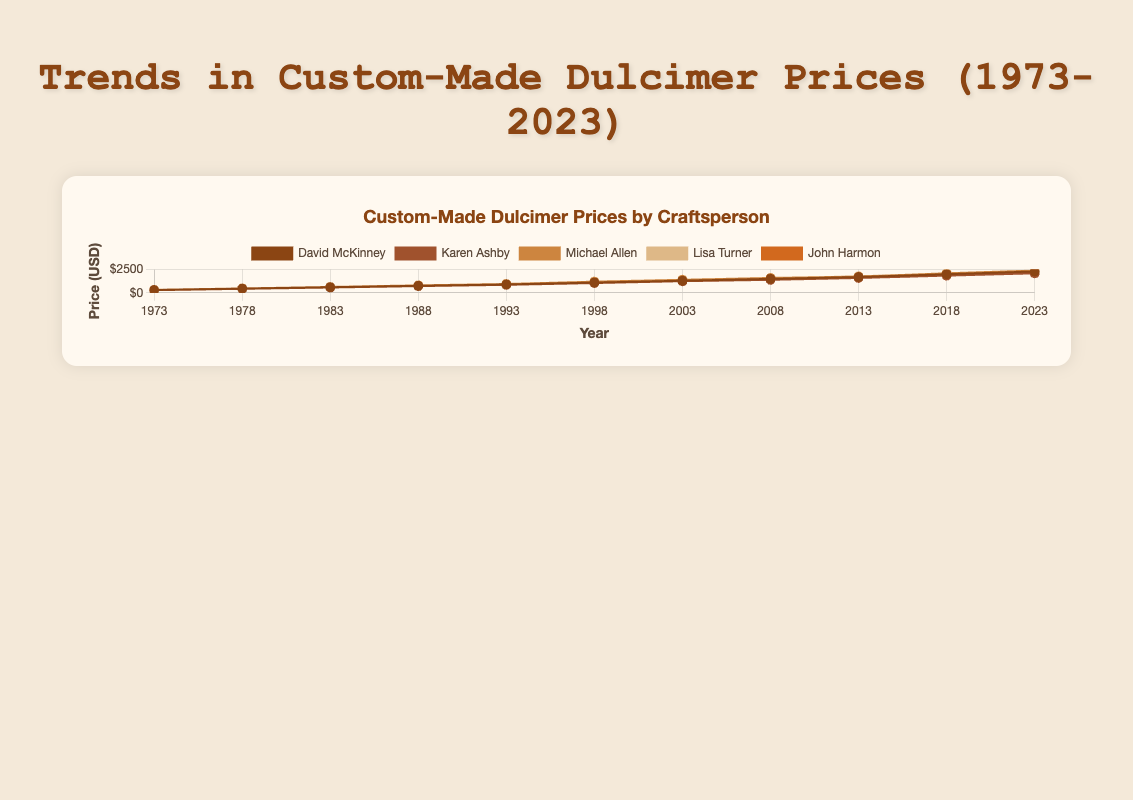Which craftsperson had the highest price for a dulcimer in 2023? To answer this, we look at the end of each line on the plot corresponding to 2023. The data points will show which craftsperson had the highest price. "Michael Allen" is the line that reaches $2400 in 2023.
Answer: Michael Allen Among all the crafters, who had the smallest price increment from 1973 to 2023? To find this, calculate the difference between the prices in 2023 and 1973 for each crafter. The differences are:
David McKinney: 2300 - 300 = 2000, Karen Ashby: 2100 - 280 = 1820, Michael Allen: 2400 - 320 = 2080, Lisa Turner: 2250 - 310 = 1940, John Harmon: 2200 - 290 = 1910. Karen Ashby has the smallest increment.
Answer: Karen Ashby Compare the prices of David McKinney and Lisa Turner in 1998. Who had the higher price? Look at the values corresponding to 1998 for both craftspersons. David McKinney had $1100, while Lisa Turner had $1150. Therefore, Lisa Turner had the higher price in 1998.
Answer: Lisa Turner Which two crafters had the closest price in 1988, and what was their price? Check the prices of all crafters in 1988: David McKinney: $750, Karen Ashby: $720, Michael Allen: $800, Lisa Turner: $770, John Harmon: $740. The closest prices are those of Karen Ashby and John Harmon, with a mere $20 difference between $720 and $740.
Answer: Karen Ashby and John Harmon, $720 and $740 Which craftsperson had the most consistent price increase over the years? Consistency in a line plot can be identified by a smooth, evenly increasing line. By visually examining the figure, David McKinney’s line shows a steady and linear increase relative to the other lines.
Answer: David McKinney What is the average price of a Michael Allen dulcimer from 1973 to 2023? Sum the prices of Michael Allen from 1973 to 2023 and divide by the number of years: (320 + 470 + 630 + 800 + 950 + 1200 + 1400 + 1600 + 1750 + 2100 + 2400) / 11 = 1460.
Answer: 1460 Which year showed the most significant increase in price for John Harmon compared to the previous year? Compare the year-over-year increments for John Harmon: 440 - 290 = 150, 590 - 440 = 150, 740 - 590 = 150, 890 - 740 = 150, 1080 - 890 = 190, 1260 - 1080 = 180, 1480 - 1260 = 220, 1670 - 1480 = 190, 1920 - 1670 = 250, 2200 - 1920 = 280. The most significant increase was between 2018 and 2023 (280).
Answer: 2018 to 2023 What is the total price difference between the highest and lowest priced dulcimer in 2023? The highest price in 2023 is $2400 (Michael Allen), and the lowest is $2100 (Karen Ashby). The difference is 2400 - 2100 = 300.
Answer: 300 